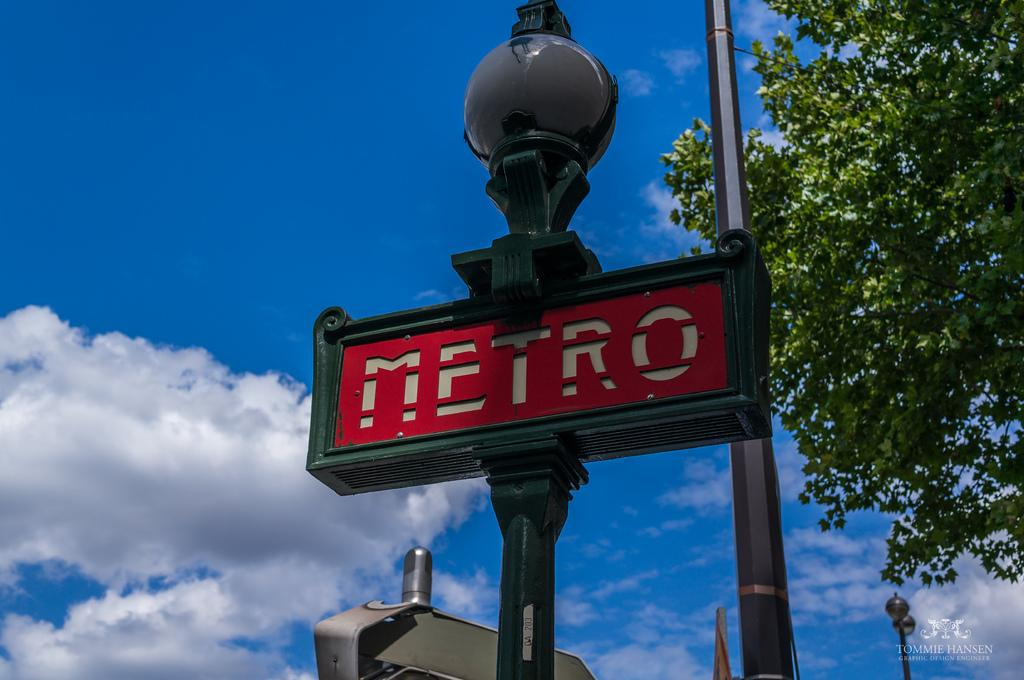What is on the pole in the image? There is a signboard on a pole in the image. What can be seen in the background of the image? There is a group of poles and a tree in the background of the image. What is visible in the sky in the image? The sky is visible in the background of the image, and it appears to be cloudy. What type of insect can be seen crawling out of the drawer in the image? There is no drawer or insect present in the image. 